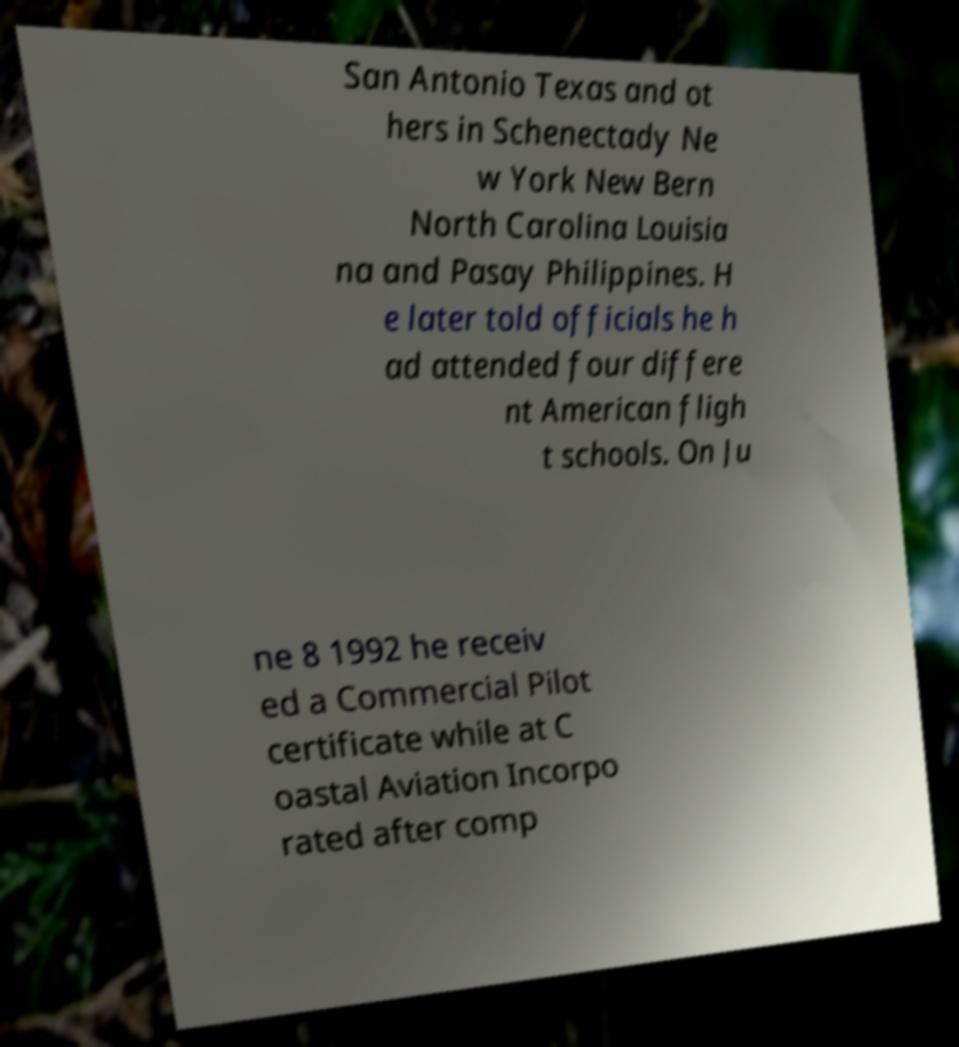What messages or text are displayed in this image? I need them in a readable, typed format. San Antonio Texas and ot hers in Schenectady Ne w York New Bern North Carolina Louisia na and Pasay Philippines. H e later told officials he h ad attended four differe nt American fligh t schools. On Ju ne 8 1992 he receiv ed a Commercial Pilot certificate while at C oastal Aviation Incorpo rated after comp 